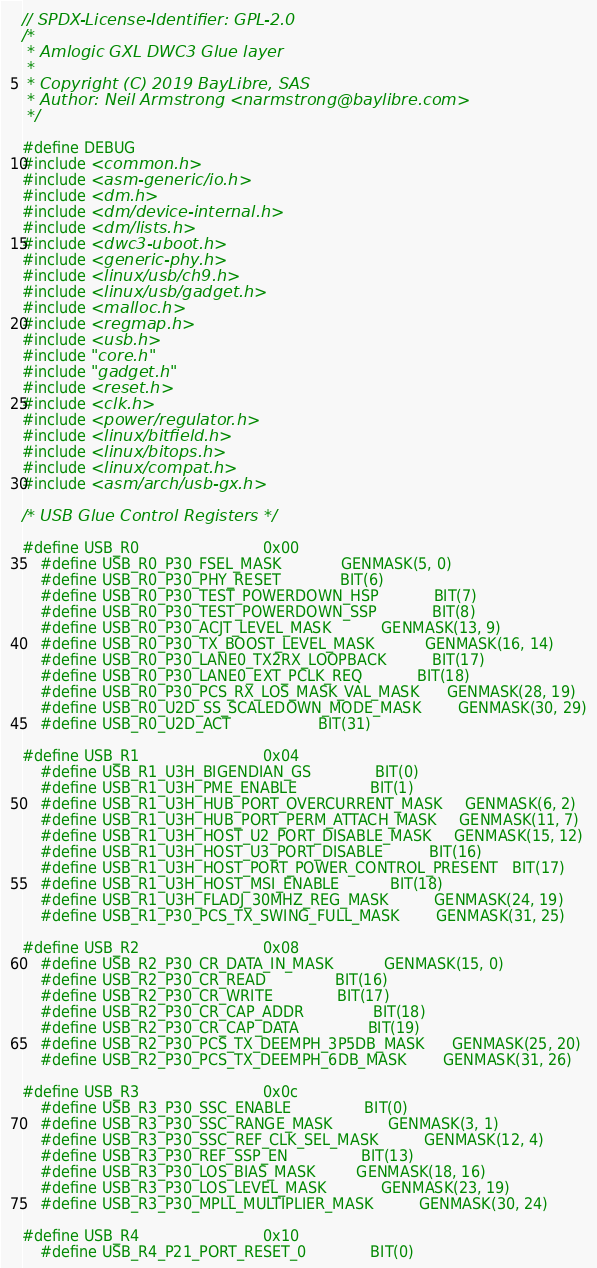<code> <loc_0><loc_0><loc_500><loc_500><_C_>// SPDX-License-Identifier: GPL-2.0
/*
 * Amlogic GXL DWC3 Glue layer
 *
 * Copyright (C) 2019 BayLibre, SAS
 * Author: Neil Armstrong <narmstrong@baylibre.com>
 */

#define DEBUG
#include <common.h>
#include <asm-generic/io.h>
#include <dm.h>
#include <dm/device-internal.h>
#include <dm/lists.h>
#include <dwc3-uboot.h>
#include <generic-phy.h>
#include <linux/usb/ch9.h>
#include <linux/usb/gadget.h>
#include <malloc.h>
#include <regmap.h>
#include <usb.h>
#include "core.h"
#include "gadget.h"
#include <reset.h>
#include <clk.h>
#include <power/regulator.h>
#include <linux/bitfield.h>
#include <linux/bitops.h>
#include <linux/compat.h>
#include <asm/arch/usb-gx.h>

/* USB Glue Control Registers */

#define USB_R0							0x00
	#define USB_R0_P30_FSEL_MASK				GENMASK(5, 0)
	#define USB_R0_P30_PHY_RESET				BIT(6)
	#define USB_R0_P30_TEST_POWERDOWN_HSP			BIT(7)
	#define USB_R0_P30_TEST_POWERDOWN_SSP			BIT(8)
	#define USB_R0_P30_ACJT_LEVEL_MASK			GENMASK(13, 9)
	#define USB_R0_P30_TX_BOOST_LEVEL_MASK			GENMASK(16, 14)
	#define USB_R0_P30_LANE0_TX2RX_LOOPBACK			BIT(17)
	#define USB_R0_P30_LANE0_EXT_PCLK_REQ			BIT(18)
	#define USB_R0_P30_PCS_RX_LOS_MASK_VAL_MASK		GENMASK(28, 19)
	#define USB_R0_U2D_SS_SCALEDOWN_MODE_MASK		GENMASK(30, 29)
	#define USB_R0_U2D_ACT					BIT(31)

#define USB_R1							0x04
	#define USB_R1_U3H_BIGENDIAN_GS				BIT(0)
	#define USB_R1_U3H_PME_ENABLE				BIT(1)
	#define USB_R1_U3H_HUB_PORT_OVERCURRENT_MASK		GENMASK(6, 2)
	#define USB_R1_U3H_HUB_PORT_PERM_ATTACH_MASK		GENMASK(11, 7)
	#define USB_R1_U3H_HOST_U2_PORT_DISABLE_MASK		GENMASK(15, 12)
	#define USB_R1_U3H_HOST_U3_PORT_DISABLE			BIT(16)
	#define USB_R1_U3H_HOST_PORT_POWER_CONTROL_PRESENT	BIT(17)
	#define USB_R1_U3H_HOST_MSI_ENABLE			BIT(18)
	#define USB_R1_U3H_FLADJ_30MHZ_REG_MASK			GENMASK(24, 19)
	#define USB_R1_P30_PCS_TX_SWING_FULL_MASK		GENMASK(31, 25)

#define USB_R2							0x08
	#define USB_R2_P30_CR_DATA_IN_MASK			GENMASK(15, 0)
	#define USB_R2_P30_CR_READ				BIT(16)
	#define USB_R2_P30_CR_WRITE				BIT(17)
	#define USB_R2_P30_CR_CAP_ADDR				BIT(18)
	#define USB_R2_P30_CR_CAP_DATA				BIT(19)
	#define USB_R2_P30_PCS_TX_DEEMPH_3P5DB_MASK		GENMASK(25, 20)
	#define USB_R2_P30_PCS_TX_DEEMPH_6DB_MASK		GENMASK(31, 26)

#define USB_R3							0x0c
	#define USB_R3_P30_SSC_ENABLE				BIT(0)
	#define USB_R3_P30_SSC_RANGE_MASK			GENMASK(3, 1)
	#define USB_R3_P30_SSC_REF_CLK_SEL_MASK			GENMASK(12, 4)
	#define USB_R3_P30_REF_SSP_EN				BIT(13)
	#define USB_R3_P30_LOS_BIAS_MASK			GENMASK(18, 16)
	#define USB_R3_P30_LOS_LEVEL_MASK			GENMASK(23, 19)
	#define USB_R3_P30_MPLL_MULTIPLIER_MASK			GENMASK(30, 24)

#define USB_R4							0x10
	#define USB_R4_P21_PORT_RESET_0				BIT(0)</code> 